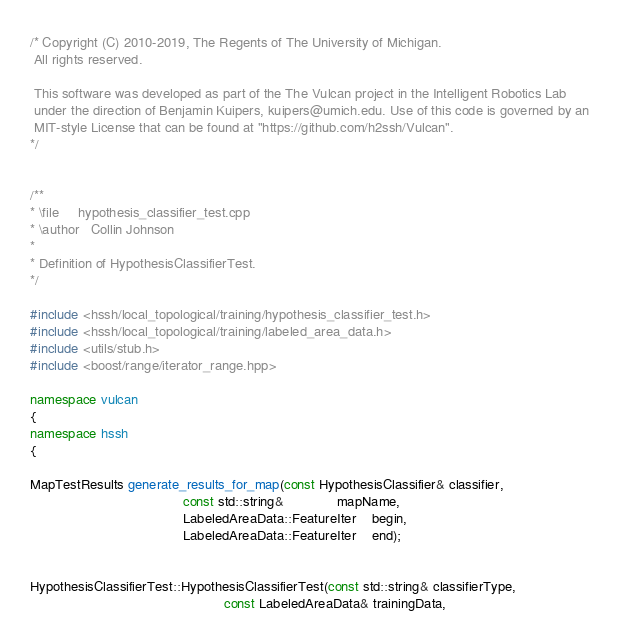<code> <loc_0><loc_0><loc_500><loc_500><_C++_>/* Copyright (C) 2010-2019, The Regents of The University of Michigan.
 All rights reserved.

 This software was developed as part of the The Vulcan project in the Intelligent Robotics Lab
 under the direction of Benjamin Kuipers, kuipers@umich.edu. Use of this code is governed by an
 MIT-style License that can be found at "https://github.com/h2ssh/Vulcan".
*/


/**
* \file     hypothesis_classifier_test.cpp
* \author   Collin Johnson
*
* Definition of HypothesisClassifierTest.
*/

#include <hssh/local_topological/training/hypothesis_classifier_test.h>
#include <hssh/local_topological/training/labeled_area_data.h>
#include <utils/stub.h>
#include <boost/range/iterator_range.hpp>

namespace vulcan
{
namespace hssh
{

MapTestResults generate_results_for_map(const HypothesisClassifier& classifier,
                                        const std::string&              mapName,
                                        LabeledAreaData::FeatureIter    begin,
                                        LabeledAreaData::FeatureIter    end);


HypothesisClassifierTest::HypothesisClassifierTest(const std::string& classifierType,
                                                   const LabeledAreaData& trainingData,</code> 